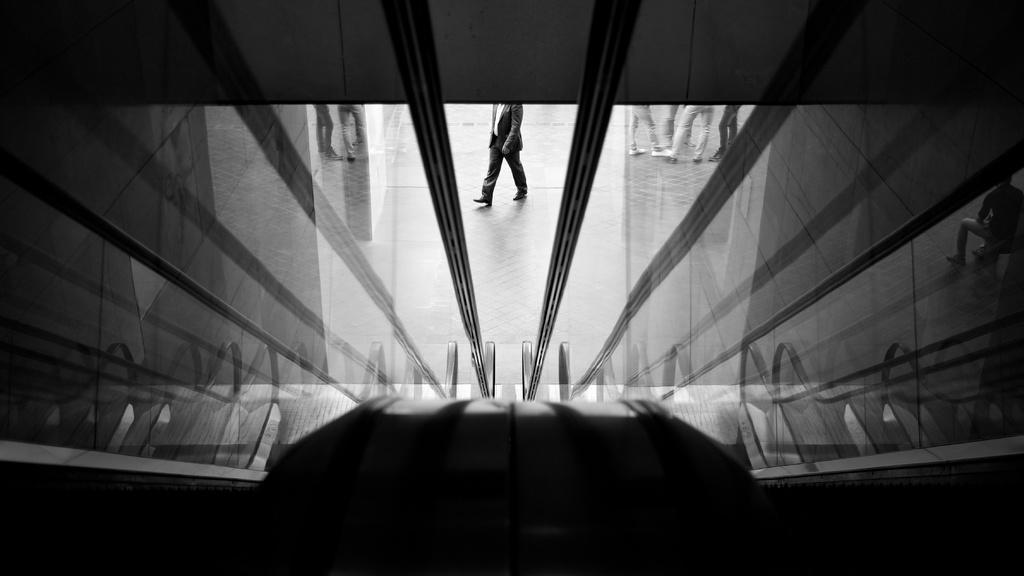Can you describe this image briefly? In this image I can see glass wall, through the wall I can see a person walking in the center, wearing a suit. Other people are standing on the right. 